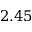<formula> <loc_0><loc_0><loc_500><loc_500>2 . 4 5</formula> 